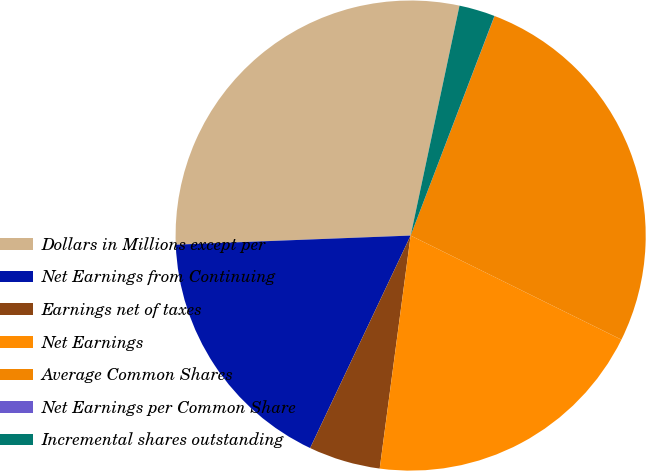Convert chart. <chart><loc_0><loc_0><loc_500><loc_500><pie_chart><fcel>Dollars in Millions except per<fcel>Net Earnings from Continuing<fcel>Earnings net of taxes<fcel>Net Earnings<fcel>Average Common Shares<fcel>Net Earnings per Common Share<fcel>Incremental shares outstanding<nl><fcel>28.95%<fcel>17.35%<fcel>4.93%<fcel>19.8%<fcel>26.49%<fcel>0.01%<fcel>2.47%<nl></chart> 